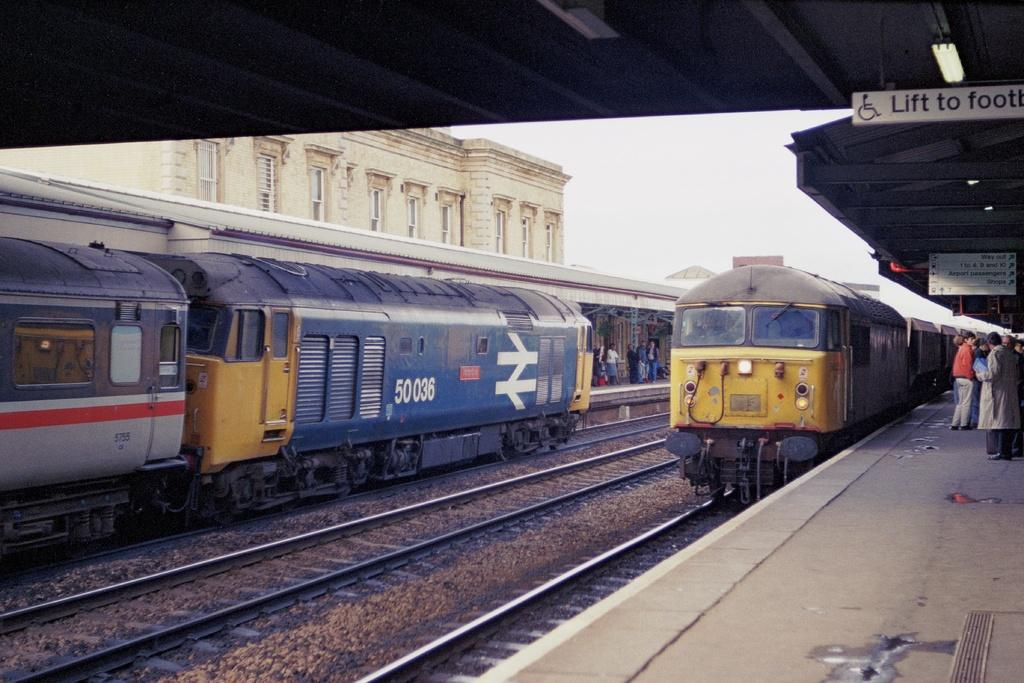Provide a one-sentence caption for the provided image. A train, numbered 50036, is at the station. 